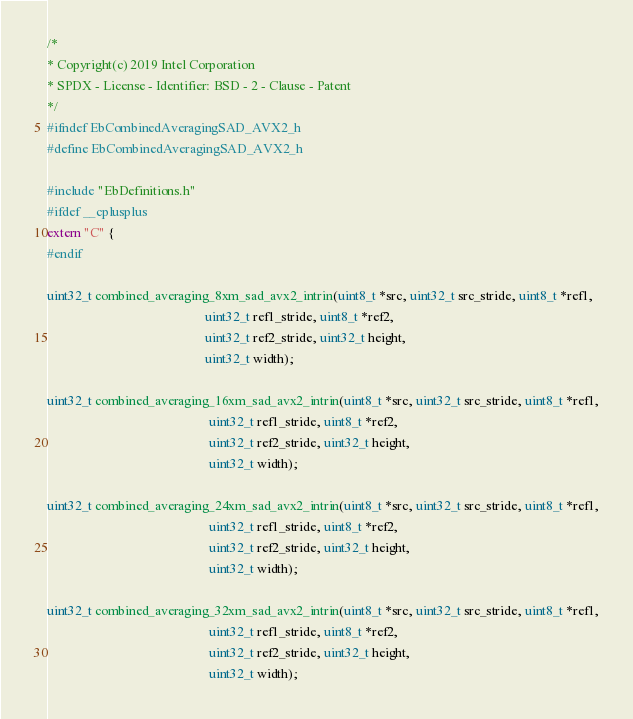<code> <loc_0><loc_0><loc_500><loc_500><_C_>/*
* Copyright(c) 2019 Intel Corporation
* SPDX - License - Identifier: BSD - 2 - Clause - Patent
*/
#ifndef EbCombinedAveragingSAD_AVX2_h
#define EbCombinedAveragingSAD_AVX2_h

#include "EbDefinitions.h"
#ifdef __cplusplus
extern "C" {
#endif

uint32_t combined_averaging_8xm_sad_avx2_intrin(uint8_t *src, uint32_t src_stride, uint8_t *ref1,
                                                uint32_t ref1_stride, uint8_t *ref2,
                                                uint32_t ref2_stride, uint32_t height,
                                                uint32_t width);

uint32_t combined_averaging_16xm_sad_avx2_intrin(uint8_t *src, uint32_t src_stride, uint8_t *ref1,
                                                 uint32_t ref1_stride, uint8_t *ref2,
                                                 uint32_t ref2_stride, uint32_t height,
                                                 uint32_t width);

uint32_t combined_averaging_24xm_sad_avx2_intrin(uint8_t *src, uint32_t src_stride, uint8_t *ref1,
                                                 uint32_t ref1_stride, uint8_t *ref2,
                                                 uint32_t ref2_stride, uint32_t height,
                                                 uint32_t width);

uint32_t combined_averaging_32xm_sad_avx2_intrin(uint8_t *src, uint32_t src_stride, uint8_t *ref1,
                                                 uint32_t ref1_stride, uint8_t *ref2,
                                                 uint32_t ref2_stride, uint32_t height,
                                                 uint32_t width);
</code> 